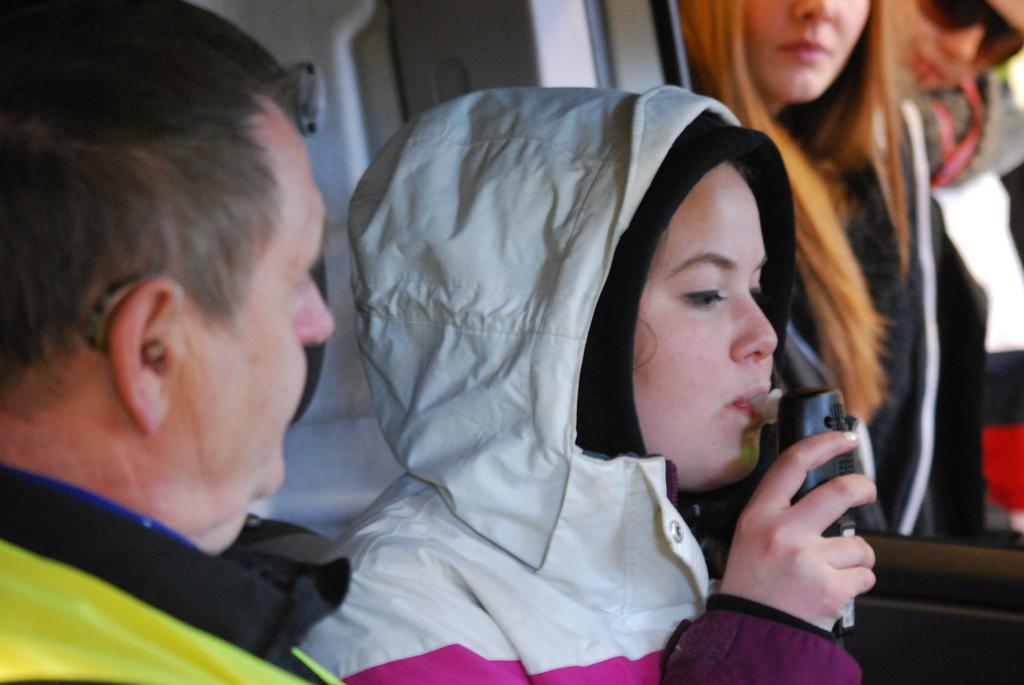In one or two sentences, can you explain what this image depicts? This is looking like an inside view of a vehicle. Here I can see a woman wearing a jacket, facing towards the right side, holding an object in the hand and kept it inside the mouth. Beside her there are three persons looking at this woman. 